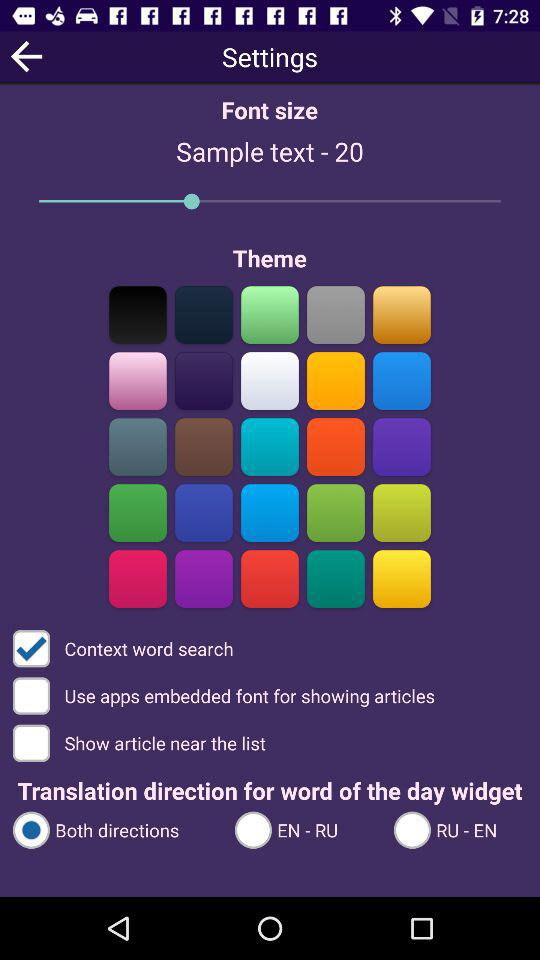What is the status of "Context word search"? The status is "on". 